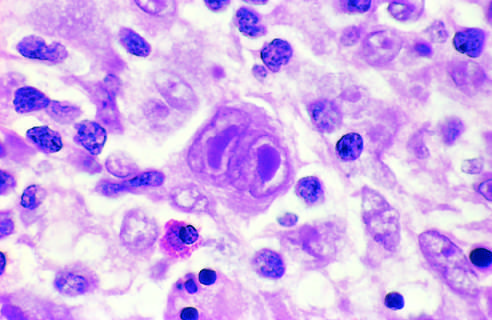s a binucleate reed-sternberg cell with large, inclusion-like nucleoli and abundant cytoplasm surrounded by lymphocytes, macrophages, and an eosinophil?
Answer the question using a single word or phrase. Yes 